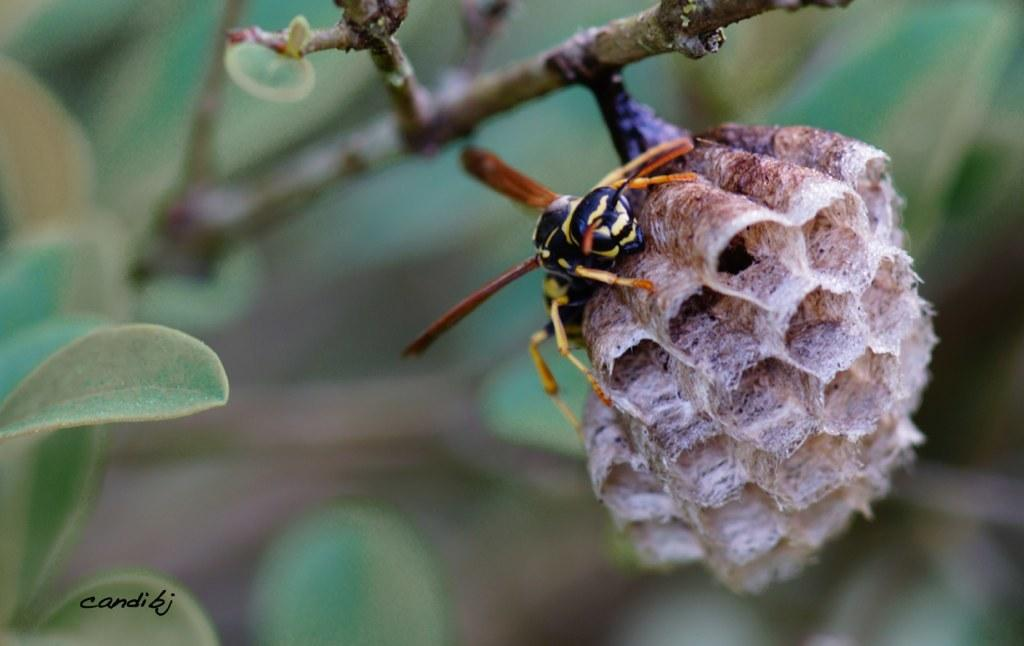What insect can be seen in the image? There is a wasp in the image. Where is the wasp located? The wasp is on a wasp nest. What is the nest attached to? The nest is on a stem. What is the appearance of the background in the image? The background of the image is blurred. Is there any text present in the image? Yes, there is text on the image. What type of bell can be heard ringing in the image? There is no bell present in the image, and therefore no sound can be heard. 